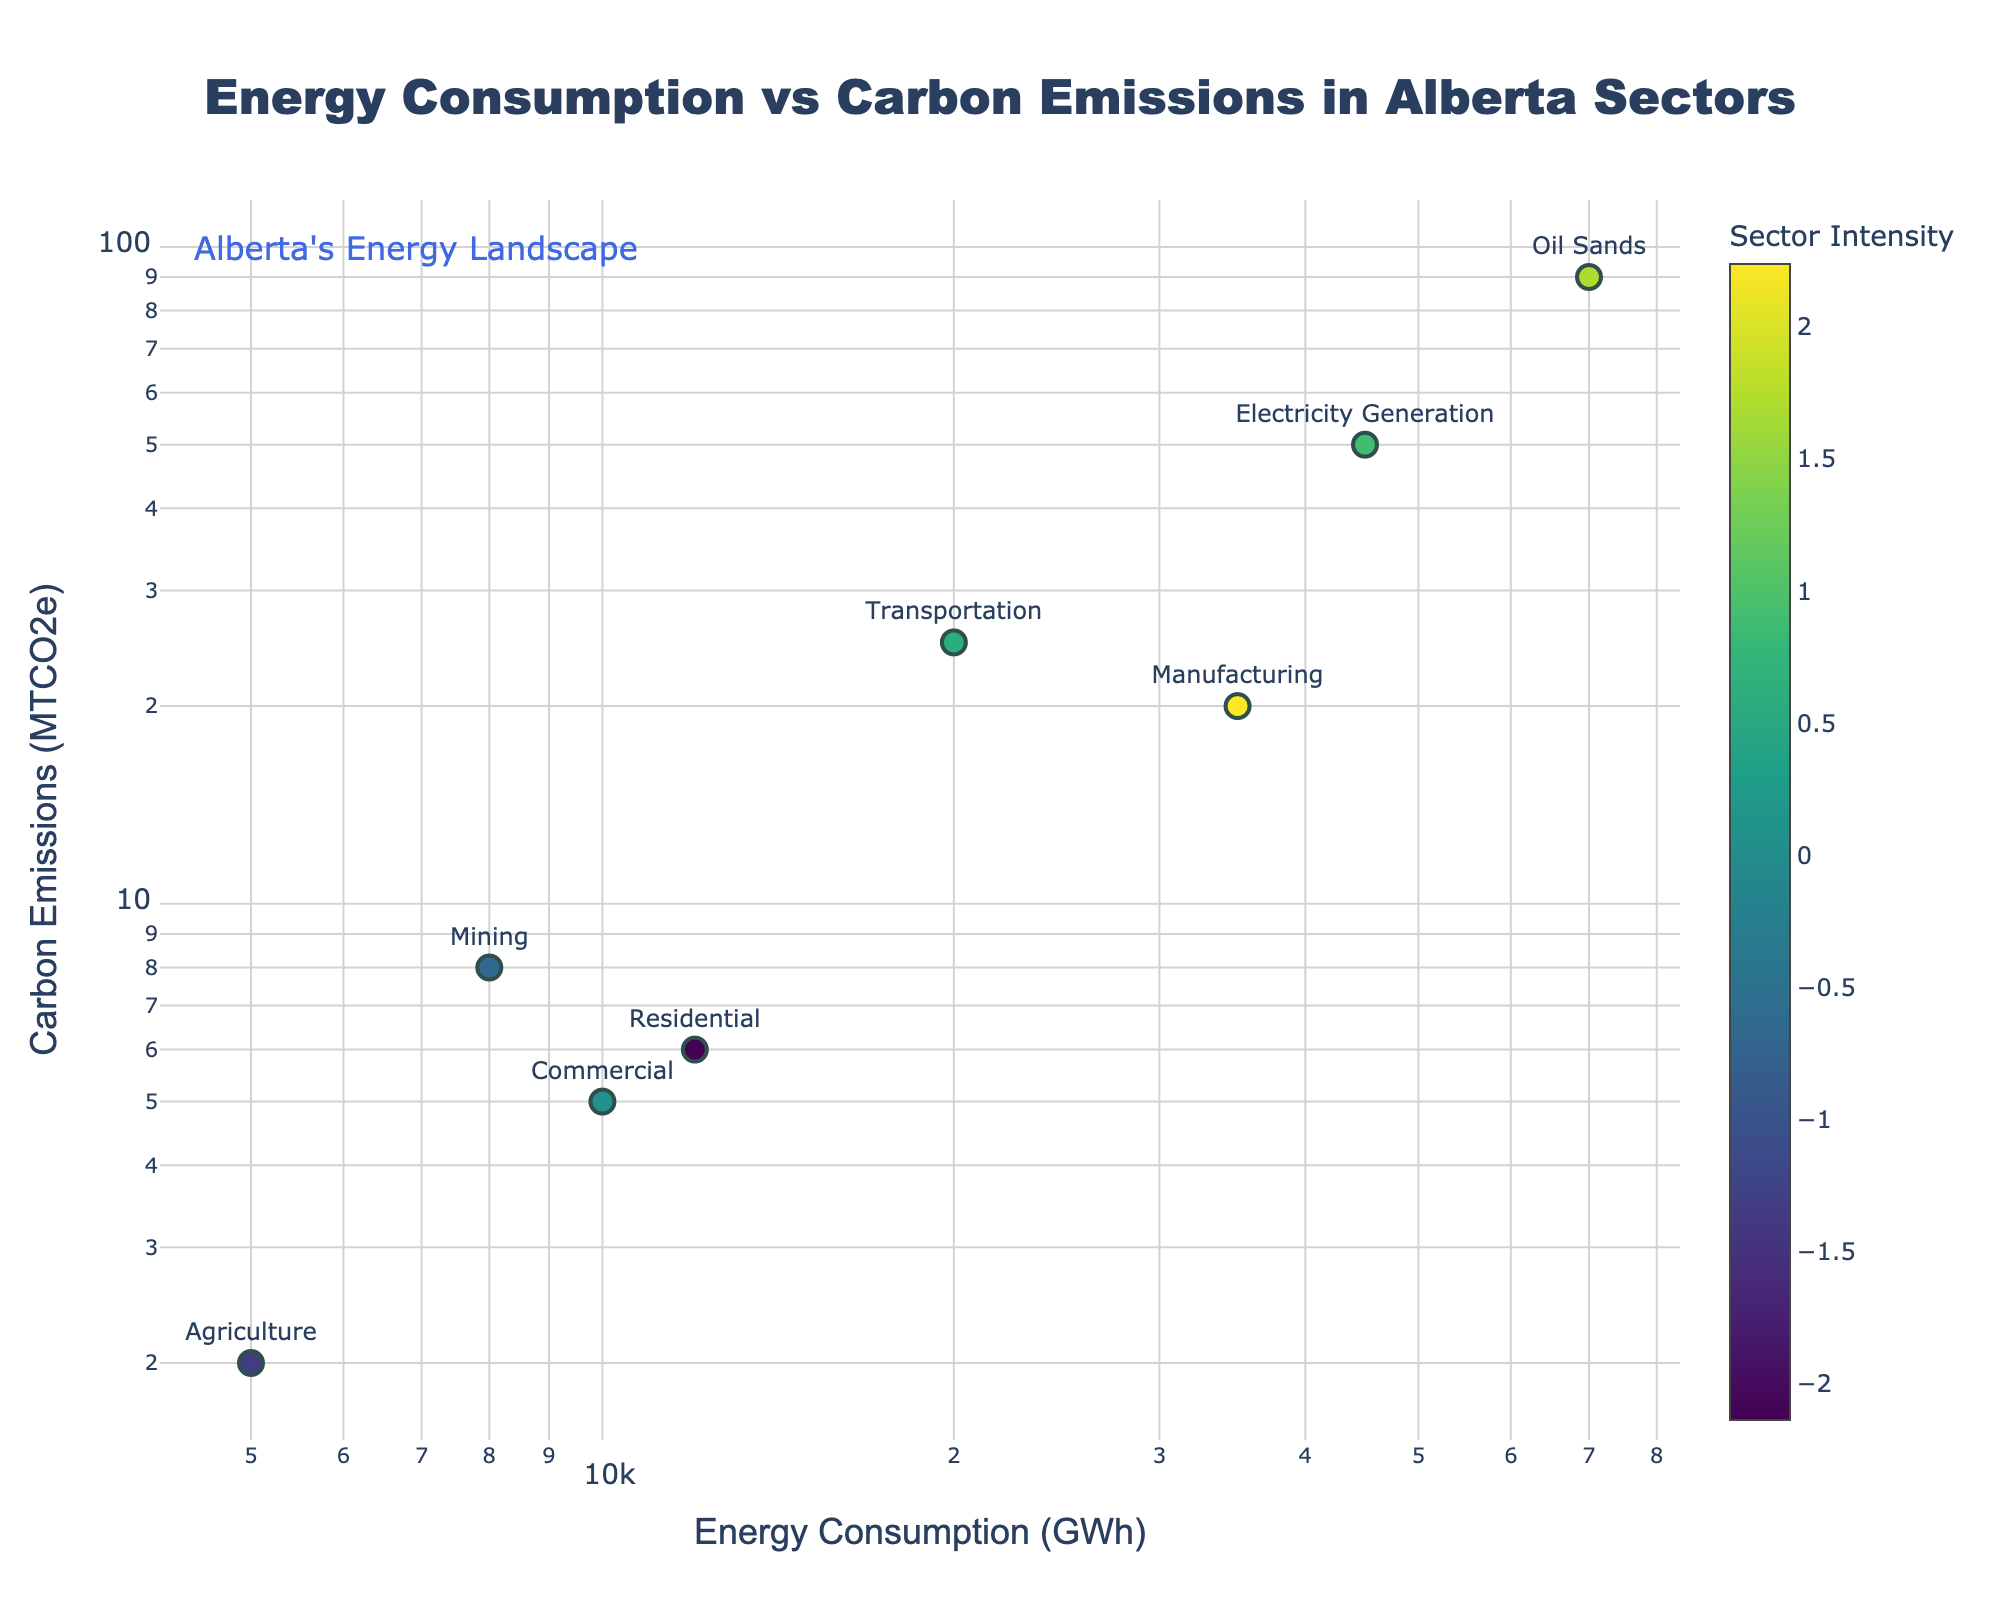Which sector has the highest carbon emissions? The sector labeled "Oil Sands" has the highest Y-axis value, which represents carbon emissions, at 90 MTCO2e.
Answer: Oil Sands What is the energy consumption of the Manufacturing sector? The point labeled "Manufacturing" corresponds to an X-axis value of 35000 GWh, indicating its energy consumption.
Answer: 35000 GWh Which sector has a lower carbon emission, Commercial or Agriculture? The Y-axis value for "Commercial" is 5 MTCO2e and for "Agriculture" is 2 MTCO2e. Comparing these values shows that Agriculture has a lower carbon emission.
Answer: Agriculture What is the combined energy consumption of the Residential and Commercial sectors? The Residential sector consumes 12000 GWh and the Commercial sector consumes 10000 GWh. Adding these together gives 12000 + 10000 = 22000 GWh.
Answer: 22000 GWh How much greater is the energy consumption of the Transportation sector compared to the Agriculture sector? The Transportation sector consumes 20000 GWh and the Agriculture sector consumes 5000 GWh. The difference is 20000 - 5000 = 15000 GWh.
Answer: 15000 GWh Which sector is more efficient in terms of carbon emissions per unit of energy consumption, Mining or Manufacturing? Calculate emissions per unit energy for Mining (8 MTCO2e / 8000 GWh = 0.001 MTCO2e/GWh) and Manufacturing (20 MTCO2e / 35000 GWh = 0.00057 MTCO2e/GWh). Manufacturing is more efficient as its value is lower.
Answer: Manufacturing How does the energy consumption of Electricity Generation compare to that of Oil Sands? The Electricity Generation sector consumes 45000 GWh and the Oil Sands sector consumes 70000 GWh. The Oil Sands sector has a higher energy consumption.
Answer: Oil Sands What is the average carbon emission of the sectors displayed? Sum the carbon emissions of all sectors (90 + 2 + 5 + 6 + 25 + 50 + 8 + 20 = 206 MTCO2e), then divide by the number of sectors (8). The average is 206 / 8 = 25.75 MTCO2e.
Answer: 25.75 MTCO2e In logarithmic scale, which sector appears closest to the median values of both axes? The median values for logarithmic energy consumption and carbon emissions will be between midrange values. Both the Commercial and Residential sectors are closest to these middle-fields visually in logarithmic scale.
Answer: Commercial or Residential 